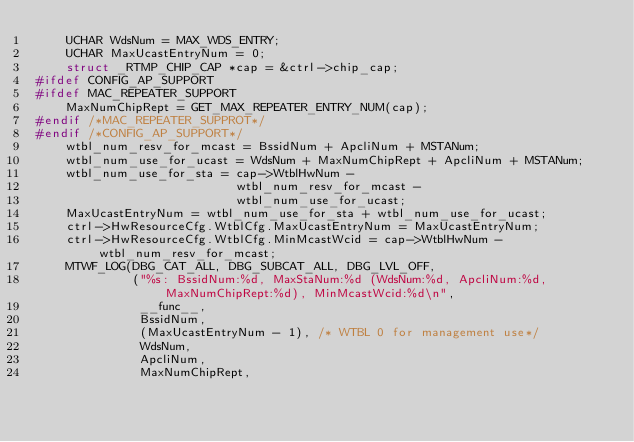Convert code to text. <code><loc_0><loc_0><loc_500><loc_500><_C_>	UCHAR WdsNum = MAX_WDS_ENTRY;
	UCHAR MaxUcastEntryNum = 0;
	struct _RTMP_CHIP_CAP *cap = &ctrl->chip_cap;
#ifdef CONFIG_AP_SUPPORT
#ifdef MAC_REPEATER_SUPPORT
	MaxNumChipRept = GET_MAX_REPEATER_ENTRY_NUM(cap);
#endif /*MAC_REPEATER_SUPPROT*/
#endif /*CONFIG_AP_SUPPORT*/
	wtbl_num_resv_for_mcast = BssidNum + ApcliNum + MSTANum;
	wtbl_num_use_for_ucast = WdsNum + MaxNumChipRept + ApcliNum + MSTANum;
	wtbl_num_use_for_sta = cap->WtblHwNum -
						   wtbl_num_resv_for_mcast -
						   wtbl_num_use_for_ucast;
	MaxUcastEntryNum = wtbl_num_use_for_sta + wtbl_num_use_for_ucast;
	ctrl->HwResourceCfg.WtblCfg.MaxUcastEntryNum = MaxUcastEntryNum;
	ctrl->HwResourceCfg.WtblCfg.MinMcastWcid = cap->WtblHwNum - wtbl_num_resv_for_mcast;
	MTWF_LOG(DBG_CAT_ALL, DBG_SUBCAT_ALL, DBG_LVL_OFF,
			 ("%s: BssidNum:%d, MaxStaNum:%d (WdsNum:%d, ApcliNum:%d, MaxNumChipRept:%d), MinMcastWcid:%d\n",
			  __func__,
			  BssidNum,
			  (MaxUcastEntryNum - 1), /* WTBL 0 for management use*/
			  WdsNum,
			  ApcliNum,
			  MaxNumChipRept,</code> 